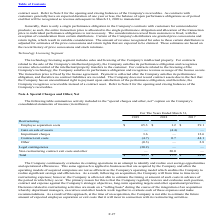According to Microchip Technology's financial document, How much was the cost incurred by the company since the start of fiscal 2016 in connection with employee separation activities? Based on the financial document, the answer is $115.2 million. Also, Which years does the table provide information for activity included in the "special charges and other, net" caption on the Company's consolidated statements of income? The document contains multiple relevant values: 2019, 2018, 2017. From the document: "2019 2018 2017 2019 2018 2017 2019 2018 2017..." Also, How much were Employee separation costs in 2019? According to the financial document, 65.3 (in millions). The relevant text states: "Employee separation costs $ 65.3 $ 1.2 $ 39.1..." Also, can you calculate: What was the change in Employee separation costs between 2017 and 2018? Based on the calculation: 1.2-39.1, the result is -37.9 (in millions). This is based on the information: "Employee separation costs $ 65.3 $ 1.2 $ 39.1 Employee separation costs $ 65.3 $ 1.2 $ 39.1..." The key data points involved are: 1.2, 39.1. Also, can you calculate: What was the change in Impairment charges between 2017 and 2019? Based on the calculation: 3.6-12.6, the result is -9 (in millions). This is based on the information: "Impairment charges 3.6 — 12.6 Impairment charges 3.6 — 12.6..." The key data points involved are: 12.6, 3.6. Also, can you calculate: What was the change in the total between 2018 and 2019? To answer this question, I need to perform calculations using the financial data. The calculation is: (33.7-17.5)/17.5, which equals 92.57 (percentage). This is based on the information: "Total $ 33.7 $ 17.5 $ 98.6 Total $ 33.7 $ 17.5 $ 98.6..." The key data points involved are: 17.5, 33.7. 